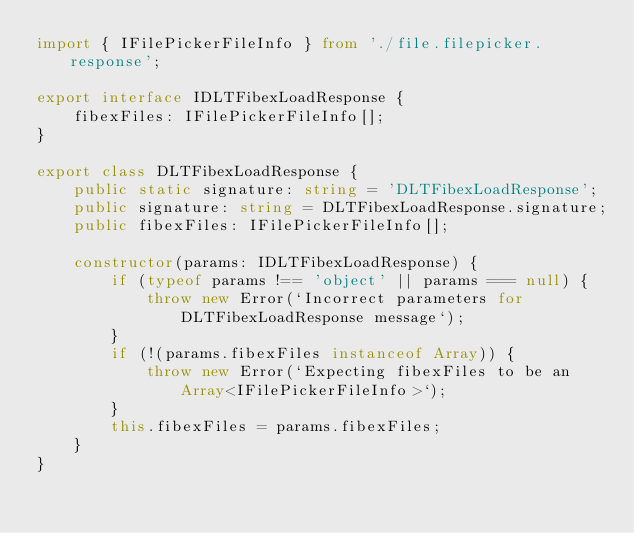<code> <loc_0><loc_0><loc_500><loc_500><_TypeScript_>import { IFilePickerFileInfo } from './file.filepicker.response';

export interface IDLTFibexLoadResponse {
    fibexFiles: IFilePickerFileInfo[];
}

export class DLTFibexLoadResponse {
    public static signature: string = 'DLTFibexLoadResponse';
    public signature: string = DLTFibexLoadResponse.signature;
    public fibexFiles: IFilePickerFileInfo[];

    constructor(params: IDLTFibexLoadResponse) {
        if (typeof params !== 'object' || params === null) {
            throw new Error(`Incorrect parameters for DLTFibexLoadResponse message`);
        }
        if (!(params.fibexFiles instanceof Array)) {
            throw new Error(`Expecting fibexFiles to be an Array<IFilePickerFileInfo>`);
        }
        this.fibexFiles = params.fibexFiles;
    }
}
</code> 